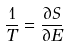<formula> <loc_0><loc_0><loc_500><loc_500>\frac { 1 } { T } = \frac { \partial S } { \partial E }</formula> 